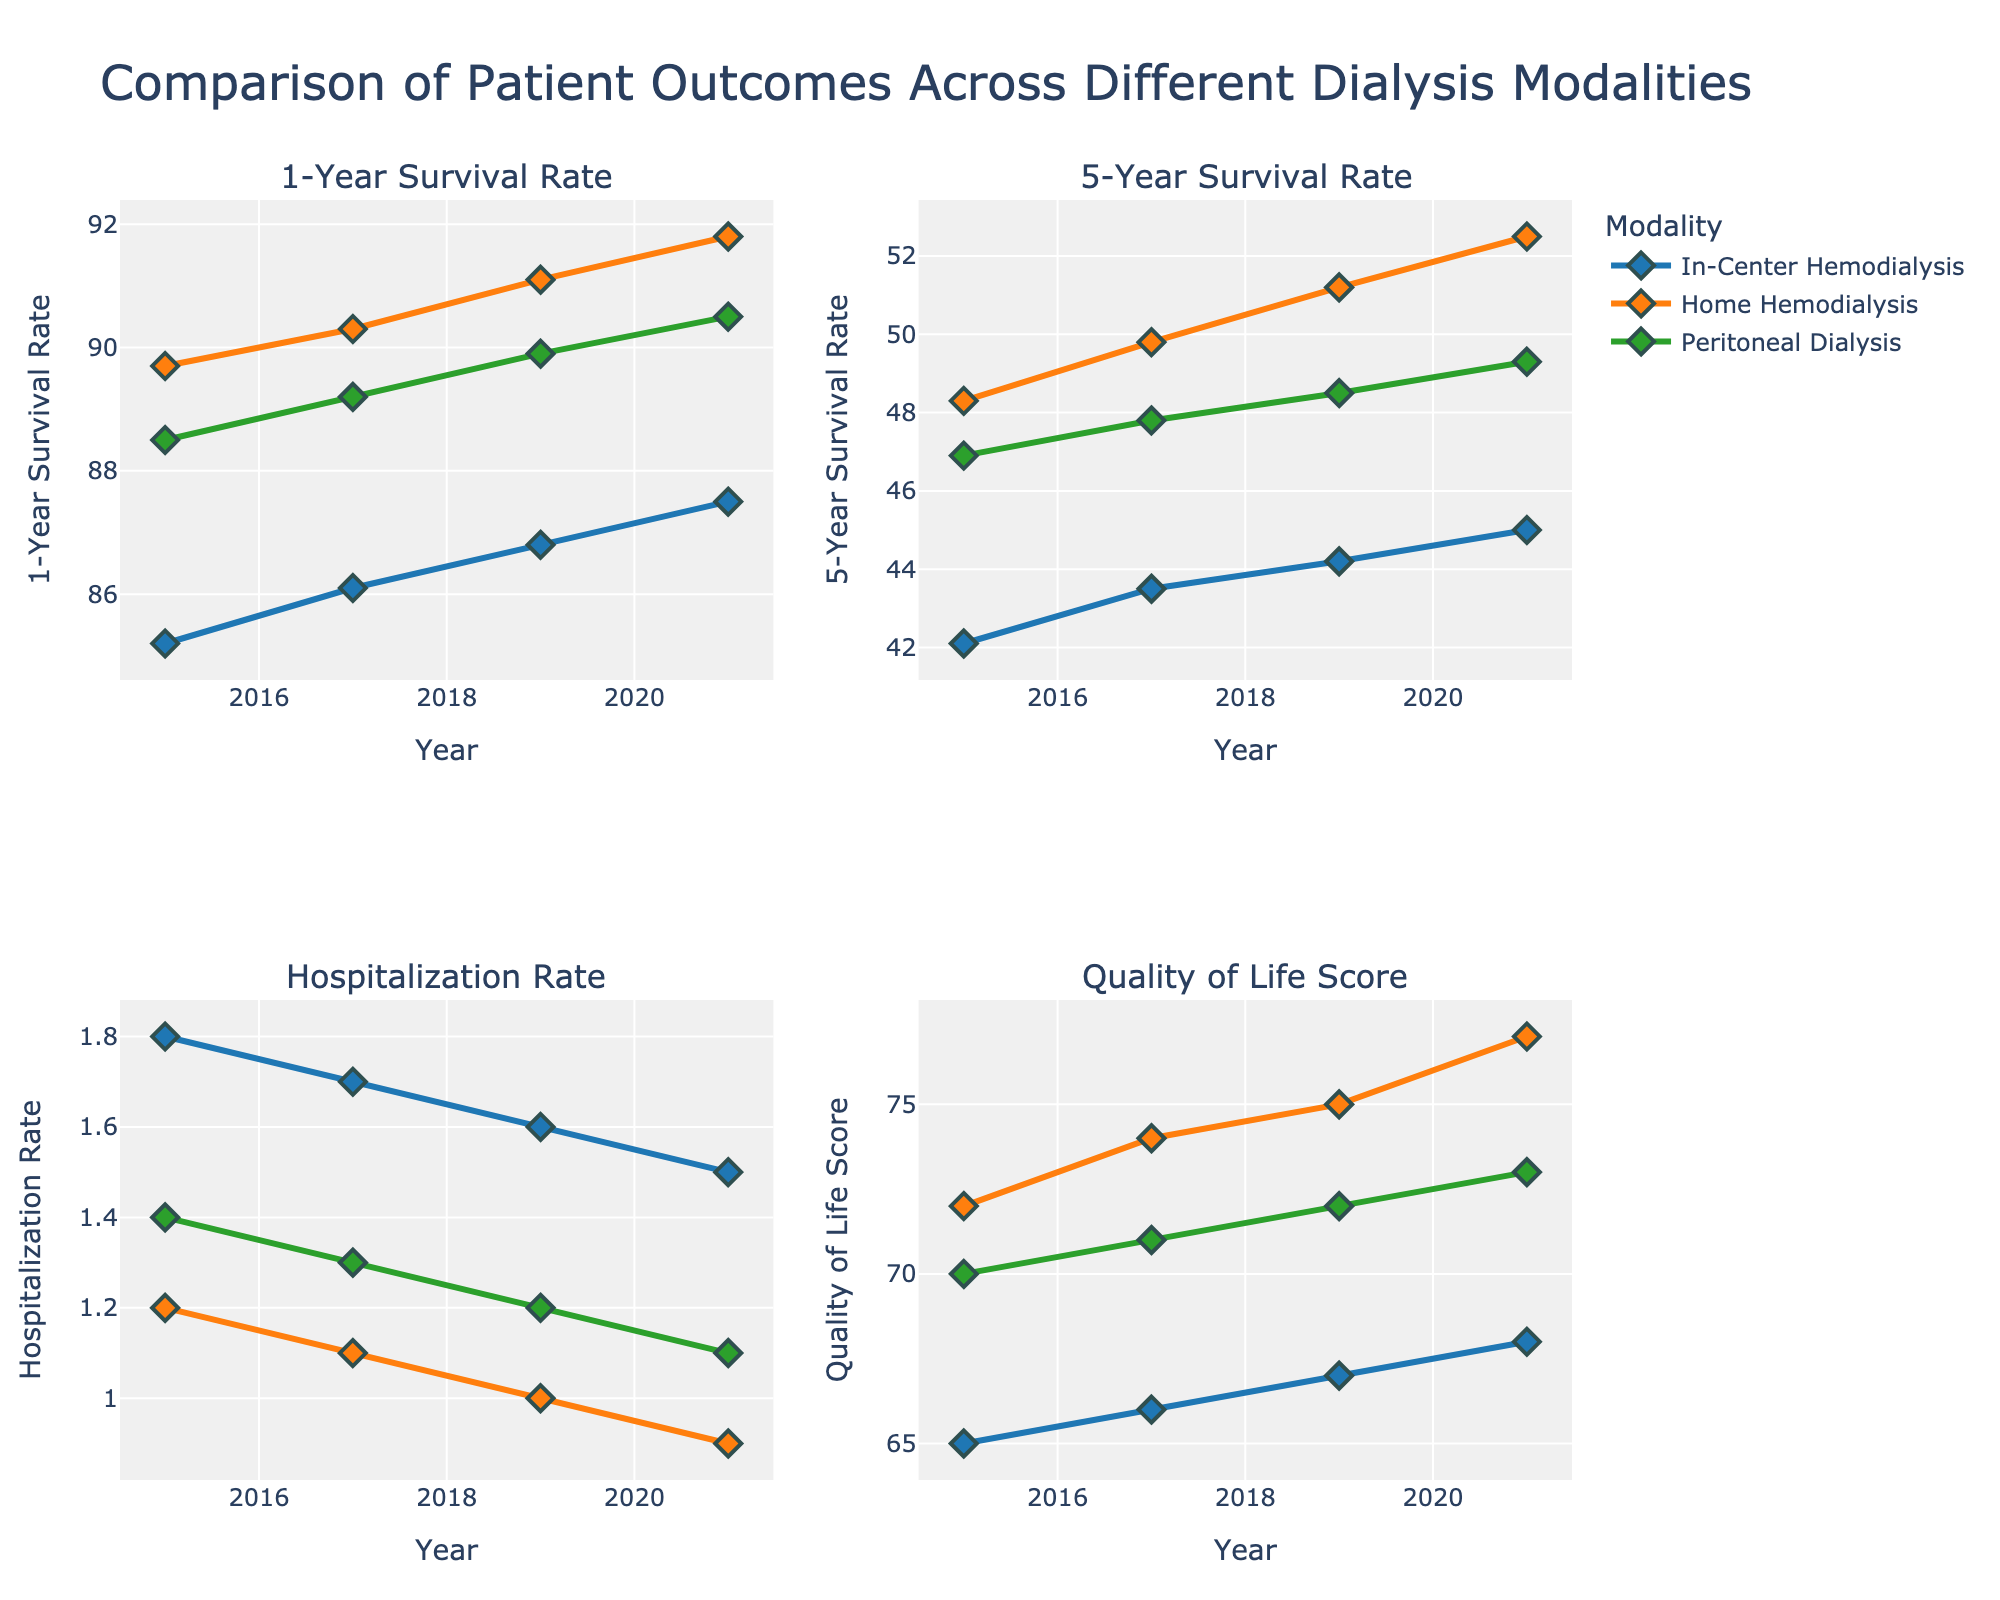What is the title of the figure? The title of the figure is displayed at the top of the plot. The title is "Comparison of Patient Outcomes Across Different Dialysis Modalities".
Answer: Comparison of Patient Outcomes Across Different Dialysis Modalities Which modality has the highest 1-Year Survival Rate in 2021? To locate this, look at the subplot titled "1-Year Survival Rate" and find the highest point for the year 2021. The orange diamond is the highest in 2021, representing Home Hemodialysis.
Answer: Home Hemodialysis How does the Hospitalization Rate for In-Center Hemodialysis change from 2015 to 2021? Observe the panel titled "Hospitalization Rate". Trace the blue line representing In-Center Hemodialysis across the years. It starts at 1.8 in 2015 and decreases to 1.5 by 2021.
Answer: It decreases from 1.8 to 1.5 Compare the 5-Year Survival Rate of Home Hemodialysis and Peritoneal Dialysis in 2017. Which modality has a higher rate? In the "5-Year Survival Rate" panel, inspect the lines for Home Hemodialysis (orange) and Peritoneal Dialysis (green) in 2017. The orange line is higher, indicating Home Hemodialysis has a higher rate.
Answer: Home Hemodialysis What is the overall trend in the Quality of Life Score for Home Hemodialysis from 2015 to 2021? Look at the "Quality of Life Score" subplot and follow the orange line for Home Hemodialysis over the years 2015 to 2021. The score increases from 72 to 77, indicating an upward trend.
Answer: Increasing Which year shows the lowest Hospitalization Rate for Peritoneal Dialysis? Check the "Hospitalization Rate" subplot and trace the green line representing Peritoneal Dialysis. The lowest point occurs in 2021 at 1.1.
Answer: 2021 How do the 5-Year Survival Rates for each modality compare in 2019? Refer to the "5-Year Survival Rate" panel for the year 2019. The rates are: In-Center Hemodialysis (44.2), Home Hemodialysis (51.2), Peritoneal Dialysis (48.5). Home Hemodialysis has the highest rate.
Answer: Home Hemodialysis > Peritoneal Dialysis > In-Center Hemodialysis What is the difference in Quality of Life Score between Home Hemodialysis and In-Center Hemodialysis in 2021? In the "Quality of Life Score" subplot, compare the orange (Home Hemodialysis, 77) and blue (In-Center Hemodialysis, 68) points for 2021. The difference is 77 - 68 = 9.
Answer: 9 Which modality shows a consistent increase in 5-Year Survival Rate over the years? Check the "5-Year Survival Rate" subplot. The orange line for Home Hemodialysis consistently rises from 2015 to 2021.
Answer: Home Hemodialysis 